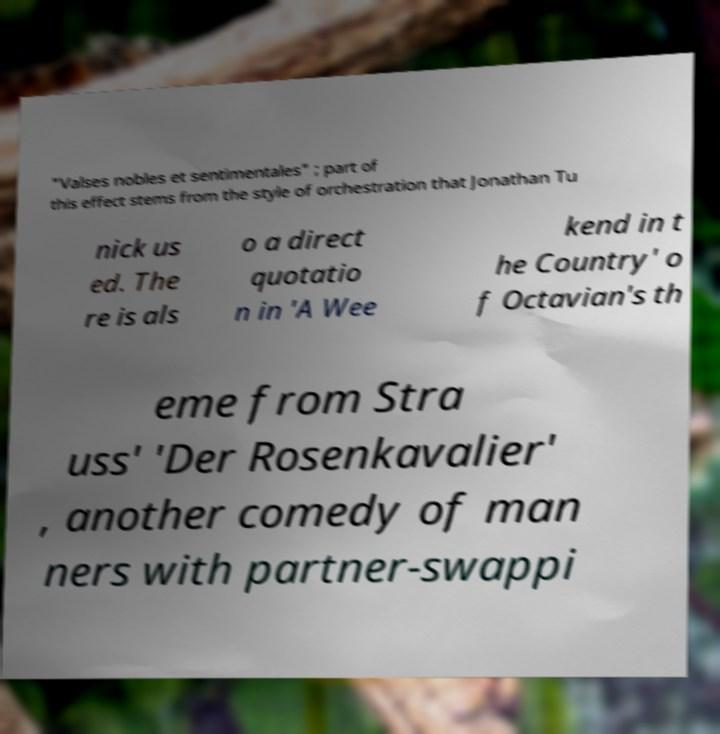Please read and relay the text visible in this image. What does it say? "Valses nobles et sentimentales" ; part of this effect stems from the style of orchestration that Jonathan Tu nick us ed. The re is als o a direct quotatio n in 'A Wee kend in t he Country' o f Octavian's th eme from Stra uss' 'Der Rosenkavalier' , another comedy of man ners with partner-swappi 